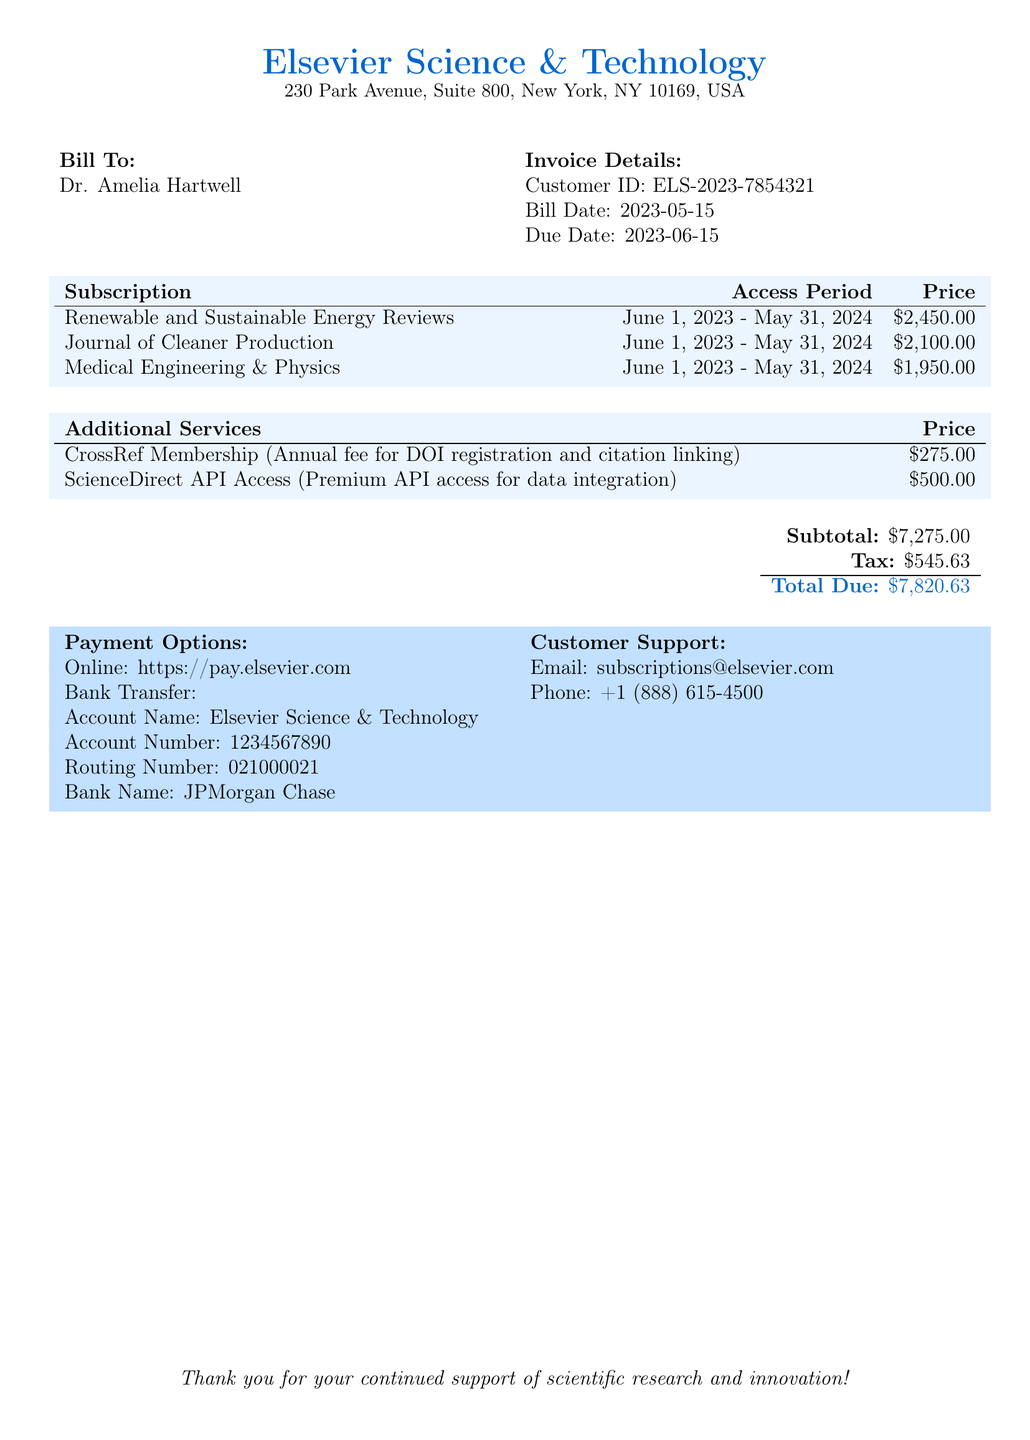What is the total amount due? The total amount due is located in the summary section, which combines the subtotal and tax.
Answer: $7,820.63 What is the customer ID? The customer ID is found in the invoice details section, specifically listed for Dr. Amelia Hartwell.
Answer: ELS-2023-7854321 What is the due date for the bill? The due date is mentioned in the invoice details section, indicating when the payment must be made.
Answer: 2023-06-15 How much is the subscription for Renewable and Sustainable Energy Reviews? The price is stated clearly in the subscriptions table, providing the cost for the service.
Answer: $2,450.00 What is the price of CrossRef Membership? The price for this additional service is specified in the additional services table of the document.
Answer: $275.00 What is the start date for the subscription period? The start date is explicitly noted in each subscription entry in the subscriptions table.
Answer: June 1, 2023 How many journals are included in this subscription renewal? The number of journals can be counted from the subscriptions table where each entry represents a different journal.
Answer: 3 Who can be contacted for customer support? The document provides a specific email and phone number for customer support regarding subscriptions.
Answer: subscriptions@elsevier.com What is the tax amount applied? The tax amount is listed in the summary section along with the subtotal.
Answer: $545.63 